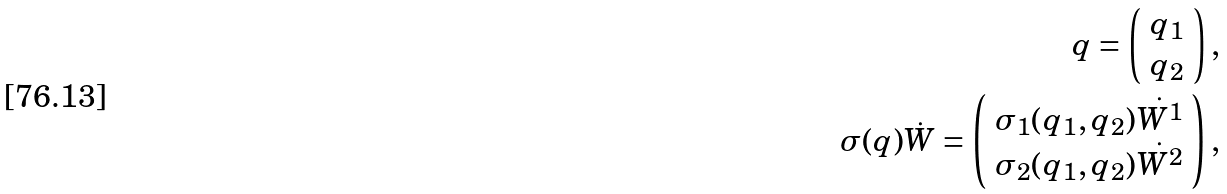Convert formula to latex. <formula><loc_0><loc_0><loc_500><loc_500>q = \left ( \begin{array} { c c } q _ { 1 } \\ q _ { 2 } \end{array} \right ) , \\ \, \sigma ( q ) \dot { W } = \left ( \begin{array} { c c } \sigma _ { 1 } ( q _ { 1 } , q _ { 2 } ) \dot { W ^ { 1 } } \\ \sigma _ { 2 } ( q _ { 1 } , q _ { 2 } ) \dot { W ^ { 2 } } \end{array} \right ) ,</formula> 